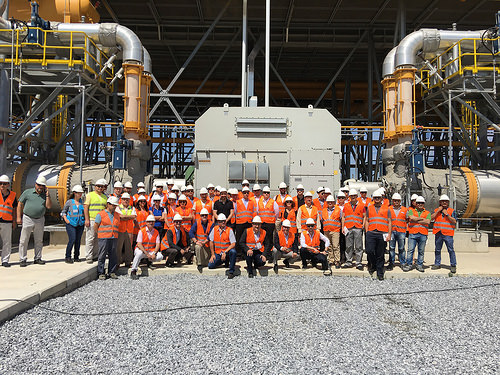<image>
Is the man on the ground? Yes. Looking at the image, I can see the man is positioned on top of the ground, with the ground providing support. Is the man on the asphalt? Yes. Looking at the image, I can see the man is positioned on top of the asphalt, with the asphalt providing support. Where is the shoe in relation to the man? Is it on the man? Yes. Looking at the image, I can see the shoe is positioned on top of the man, with the man providing support. 